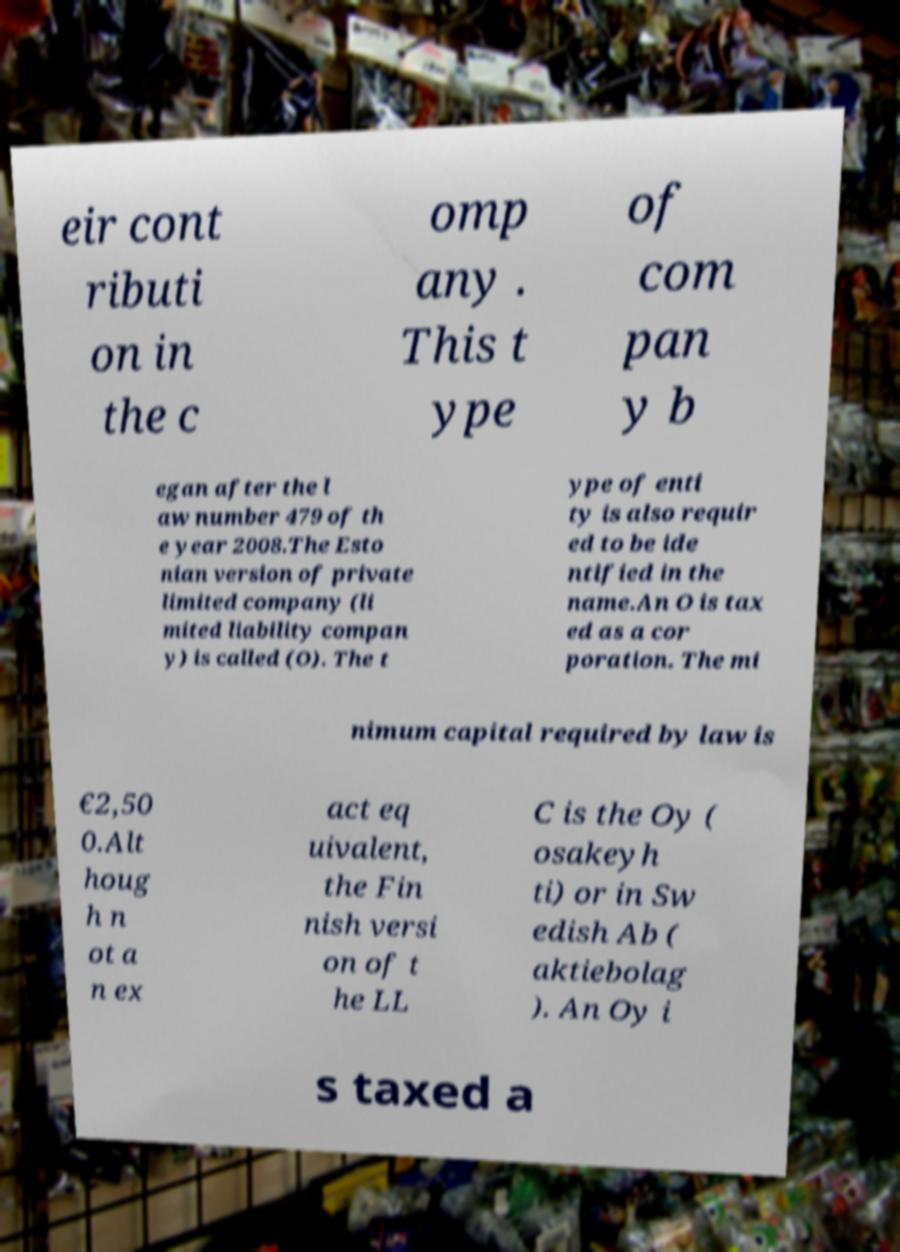Please read and relay the text visible in this image. What does it say? eir cont ributi on in the c omp any . This t ype of com pan y b egan after the l aw number 479 of th e year 2008.The Esto nian version of private limited company (li mited liability compan y) is called (O). The t ype of enti ty is also requir ed to be ide ntified in the name.An O is tax ed as a cor poration. The mi nimum capital required by law is €2,50 0.Alt houg h n ot a n ex act eq uivalent, the Fin nish versi on of t he LL C is the Oy ( osakeyh ti) or in Sw edish Ab ( aktiebolag ). An Oy i s taxed a 